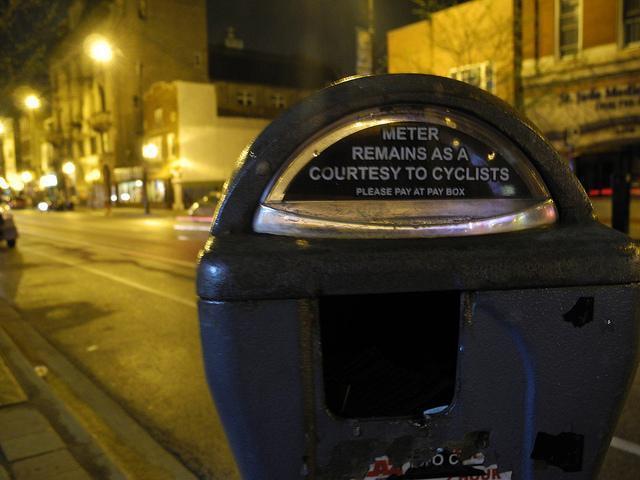How many coins does the machine need?
Give a very brief answer. 0. 